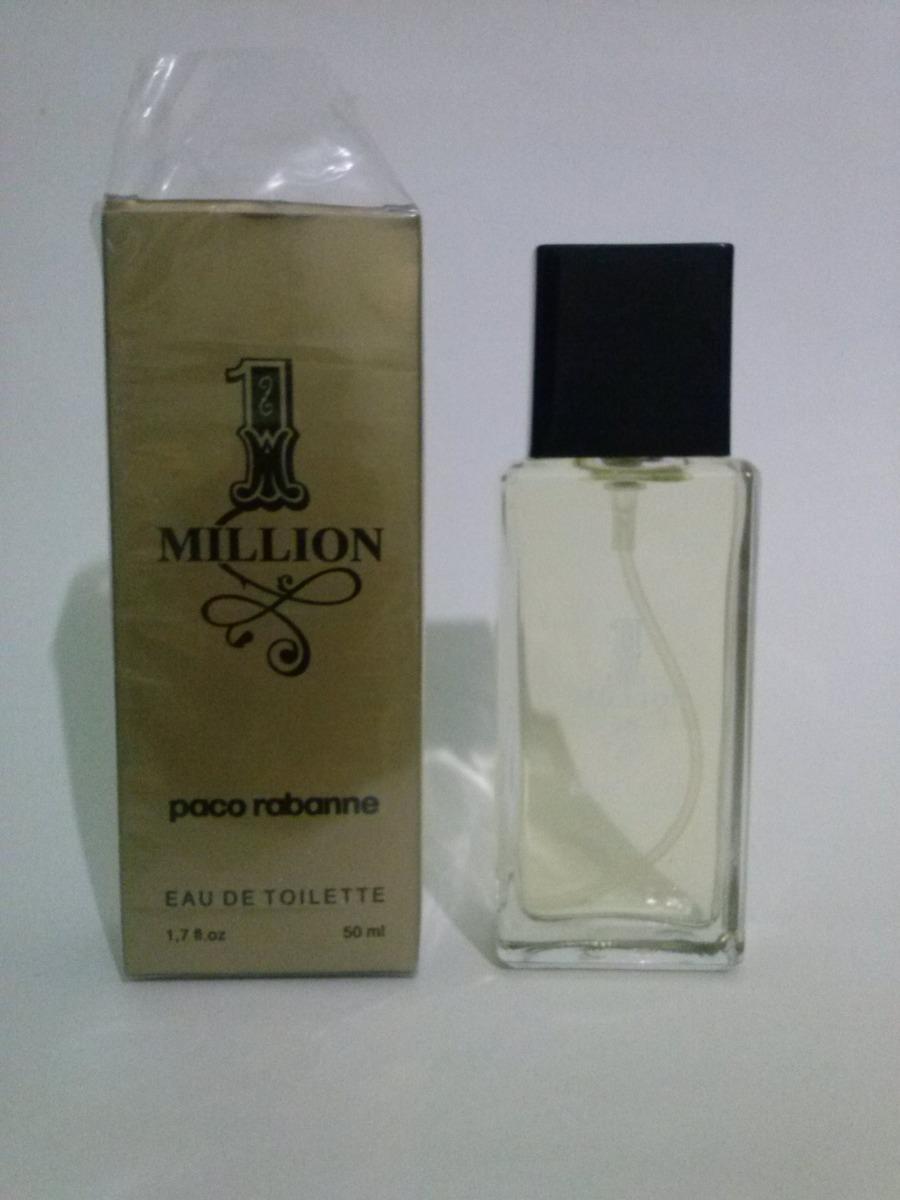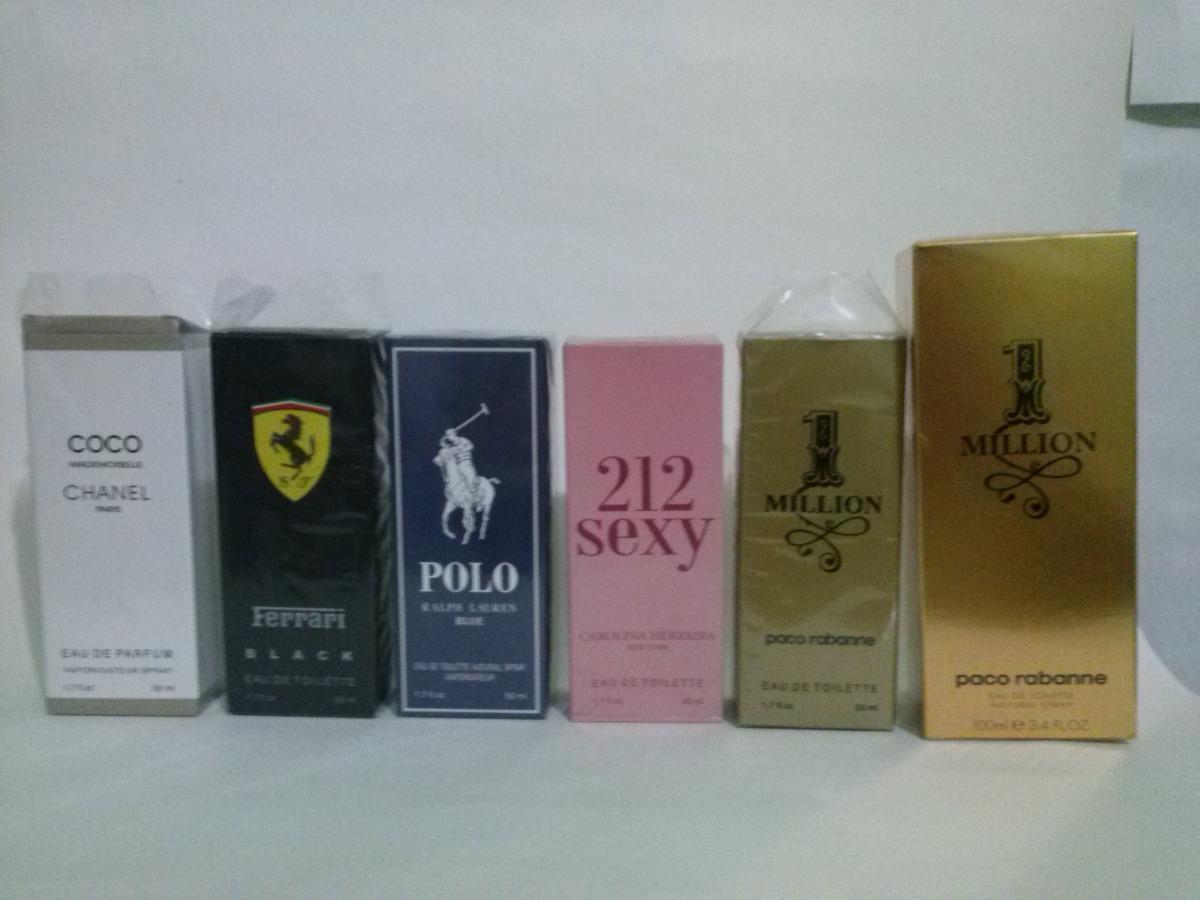The first image is the image on the left, the second image is the image on the right. Given the left and right images, does the statement "There is a cologne bottle displaying the number 212 on its side." hold true? Answer yes or no. No. The first image is the image on the left, the second image is the image on the right. Examine the images to the left and right. Is the description "There is a total of 1 black box." accurate? Answer yes or no. Yes. 